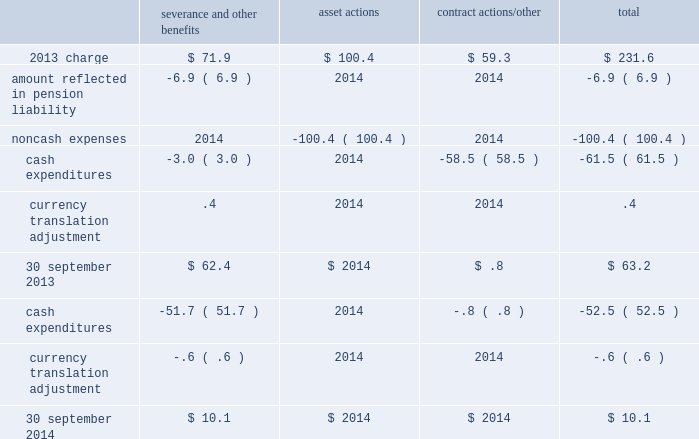Business restructuring and cost reduction actions the charges we record for business restructuring and cost reduction actions have been excluded from segment operating income and are reflected on the consolidated income statements as 201cbusiness restructuring and cost reduction actions . 201d 2014 charge on 18 september 2014 , we announced plans to reorganize the company , including realignment of our businesses in new reporting segments and organizational changes , effective as of 1 october 2014 .
Refer to note 25 , business segment and geographic information , for additional details .
As a result of this initiative , we will incur ongoing severance and other charges .
During the fourth quarter of 2014 , an expense of $ 12.7 ( $ 8.2 after-tax , or $ .04 per share ) was incurred relating to the elimination of approximately 50 positions .
The 2014 charge related to the businesses at the segment level as follows : $ 4.4 in merchant gases , $ 4.1 in tonnage gases , $ 2.4 in electronics and performance materials , and $ 1.8 in equipment and energy .
2013 plan during the fourth quarter of 2013 , we recorded an expense of $ 231.6 ( $ 157.9 after-tax , or $ .74 per share ) reflecting actions to better align our cost structure with current market conditions .
The asset and contract actions primarily impacted the electronics business due to continued weakness in the photovoltaic ( pv ) and light-emitting diode ( led ) markets .
The severance and other contractual benefits primarily impacted our merchant gases business and corporate functions in response to weaker than expected business conditions in europe and asia , reorganization of our operations and functional areas , and previously announced senior executive changes .
The remaining planned actions associated with severance were completed in the first quarter of 2015 .
The 2013 charges relate to the businesses at the segment level as follows : $ 61.0 in merchant gases , $ 28.6 in tonnage gases , $ 141.0 in electronics and performance materials , and $ 1.0 in equipment and energy .
The table summarizes the carrying amount of the accrual for the 2013 plan at 30 september 2014 : severance and other benefits actions contract actions/other total .

Taking into account the 2014 charge related to the businesses for a segment , what is the percentage of the merchant gases segment concerning all of them? 
Rationale: it is the value of the merchant gases segment divided by the sum of all segments , then turned into a percentage .
Computations: (4.4 / ((4.4 + 4.1) + (2.4 + 1.8)))
Answer: 0.34646. 